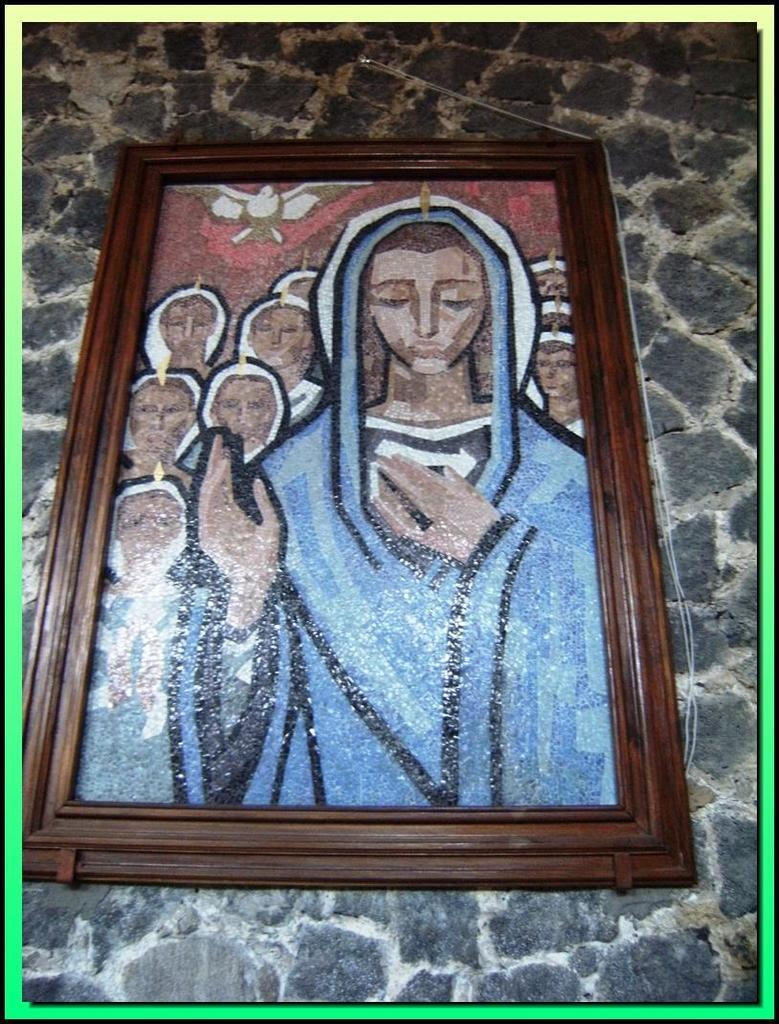What type of artwork is shown in the image? The image is a painting. What is the main subject of the painting? The painting depicts a woman. What color is the woman wearing in the painting? The woman is wearing blue color. Can you describe any other elements in the painting besides the woman? Yes, there is a bird at the top of the painting. Where is the spot on the woman's dress in the painting? There is no spot mentioned or visible on the woman's dress in the painting. What type of knife is the woman holding in the painting? There is no knife present in the painting; the woman is not holding any such object. 